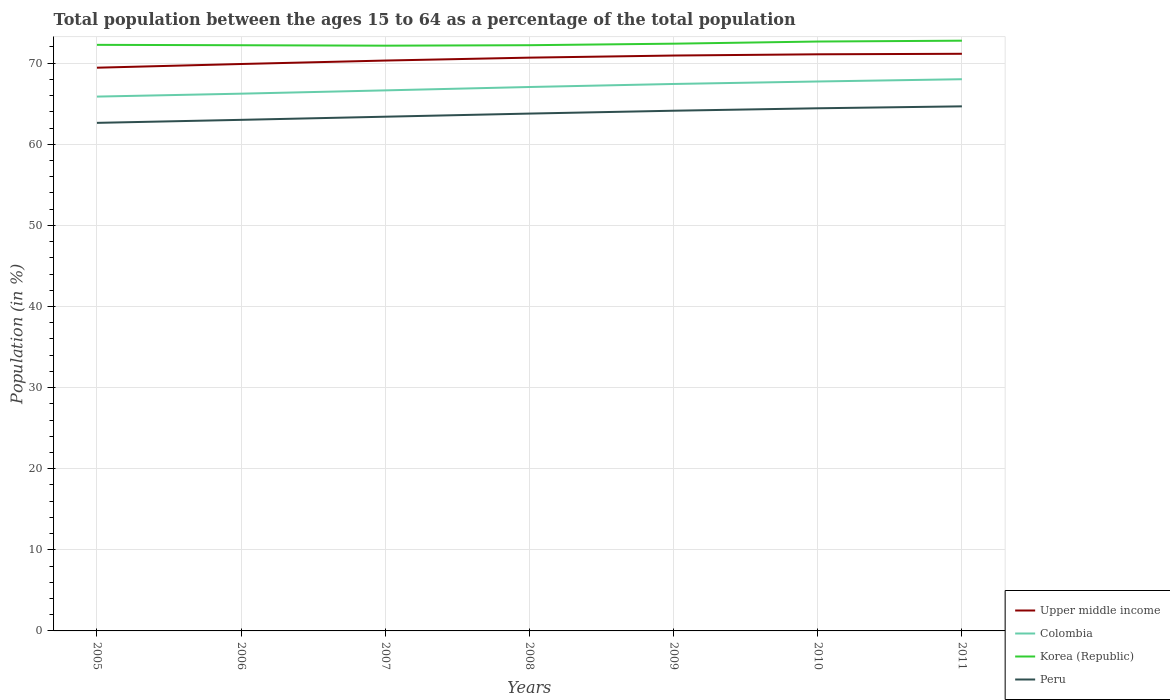Across all years, what is the maximum percentage of the population ages 15 to 64 in Korea (Republic)?
Your answer should be compact. 72.16. In which year was the percentage of the population ages 15 to 64 in Peru maximum?
Keep it short and to the point. 2005. What is the total percentage of the population ages 15 to 64 in Korea (Republic) in the graph?
Provide a short and direct response. -0.25. What is the difference between the highest and the second highest percentage of the population ages 15 to 64 in Peru?
Provide a succinct answer. 2.04. What is the difference between the highest and the lowest percentage of the population ages 15 to 64 in Upper middle income?
Make the answer very short. 4. Are the values on the major ticks of Y-axis written in scientific E-notation?
Ensure brevity in your answer.  No. Does the graph contain any zero values?
Ensure brevity in your answer.  No. Where does the legend appear in the graph?
Make the answer very short. Bottom right. How many legend labels are there?
Give a very brief answer. 4. How are the legend labels stacked?
Offer a terse response. Vertical. What is the title of the graph?
Your answer should be very brief. Total population between the ages 15 to 64 as a percentage of the total population. Does "American Samoa" appear as one of the legend labels in the graph?
Offer a very short reply. No. What is the Population (in %) in Upper middle income in 2005?
Ensure brevity in your answer.  69.44. What is the Population (in %) in Colombia in 2005?
Ensure brevity in your answer.  65.88. What is the Population (in %) of Korea (Republic) in 2005?
Ensure brevity in your answer.  72.26. What is the Population (in %) in Peru in 2005?
Ensure brevity in your answer.  62.64. What is the Population (in %) in Upper middle income in 2006?
Your answer should be compact. 69.9. What is the Population (in %) of Colombia in 2006?
Provide a succinct answer. 66.24. What is the Population (in %) of Korea (Republic) in 2006?
Your answer should be very brief. 72.21. What is the Population (in %) of Peru in 2006?
Offer a very short reply. 63.01. What is the Population (in %) in Upper middle income in 2007?
Keep it short and to the point. 70.33. What is the Population (in %) of Colombia in 2007?
Provide a succinct answer. 66.65. What is the Population (in %) in Korea (Republic) in 2007?
Give a very brief answer. 72.16. What is the Population (in %) of Peru in 2007?
Offer a very short reply. 63.4. What is the Population (in %) in Upper middle income in 2008?
Ensure brevity in your answer.  70.68. What is the Population (in %) of Colombia in 2008?
Offer a very short reply. 67.06. What is the Population (in %) in Korea (Republic) in 2008?
Your response must be concise. 72.22. What is the Population (in %) of Peru in 2008?
Keep it short and to the point. 63.79. What is the Population (in %) in Upper middle income in 2009?
Make the answer very short. 70.94. What is the Population (in %) of Colombia in 2009?
Offer a very short reply. 67.44. What is the Population (in %) in Korea (Republic) in 2009?
Offer a terse response. 72.41. What is the Population (in %) of Peru in 2009?
Keep it short and to the point. 64.14. What is the Population (in %) in Upper middle income in 2010?
Provide a short and direct response. 71.1. What is the Population (in %) of Colombia in 2010?
Provide a succinct answer. 67.74. What is the Population (in %) in Korea (Republic) in 2010?
Your answer should be compact. 72.67. What is the Population (in %) in Peru in 2010?
Your answer should be very brief. 64.44. What is the Population (in %) of Upper middle income in 2011?
Your answer should be very brief. 71.16. What is the Population (in %) in Colombia in 2011?
Give a very brief answer. 68.02. What is the Population (in %) of Korea (Republic) in 2011?
Keep it short and to the point. 72.77. What is the Population (in %) in Peru in 2011?
Keep it short and to the point. 64.68. Across all years, what is the maximum Population (in %) in Upper middle income?
Provide a succinct answer. 71.16. Across all years, what is the maximum Population (in %) in Colombia?
Your answer should be very brief. 68.02. Across all years, what is the maximum Population (in %) in Korea (Republic)?
Your answer should be very brief. 72.77. Across all years, what is the maximum Population (in %) of Peru?
Offer a terse response. 64.68. Across all years, what is the minimum Population (in %) of Upper middle income?
Provide a short and direct response. 69.44. Across all years, what is the minimum Population (in %) in Colombia?
Your answer should be very brief. 65.88. Across all years, what is the minimum Population (in %) of Korea (Republic)?
Your answer should be very brief. 72.16. Across all years, what is the minimum Population (in %) in Peru?
Your answer should be compact. 62.64. What is the total Population (in %) of Upper middle income in the graph?
Keep it short and to the point. 493.55. What is the total Population (in %) in Colombia in the graph?
Give a very brief answer. 469.04. What is the total Population (in %) in Korea (Republic) in the graph?
Make the answer very short. 506.7. What is the total Population (in %) in Peru in the graph?
Offer a terse response. 446.11. What is the difference between the Population (in %) of Upper middle income in 2005 and that in 2006?
Your answer should be compact. -0.46. What is the difference between the Population (in %) of Colombia in 2005 and that in 2006?
Offer a very short reply. -0.36. What is the difference between the Population (in %) in Korea (Republic) in 2005 and that in 2006?
Keep it short and to the point. 0.05. What is the difference between the Population (in %) of Peru in 2005 and that in 2006?
Make the answer very short. -0.37. What is the difference between the Population (in %) in Upper middle income in 2005 and that in 2007?
Provide a short and direct response. -0.88. What is the difference between the Population (in %) in Colombia in 2005 and that in 2007?
Your answer should be compact. -0.77. What is the difference between the Population (in %) of Korea (Republic) in 2005 and that in 2007?
Keep it short and to the point. 0.1. What is the difference between the Population (in %) in Peru in 2005 and that in 2007?
Your answer should be compact. -0.76. What is the difference between the Population (in %) of Upper middle income in 2005 and that in 2008?
Your answer should be very brief. -1.24. What is the difference between the Population (in %) in Colombia in 2005 and that in 2008?
Your answer should be very brief. -1.18. What is the difference between the Population (in %) of Korea (Republic) in 2005 and that in 2008?
Your response must be concise. 0.05. What is the difference between the Population (in %) in Peru in 2005 and that in 2008?
Make the answer very short. -1.14. What is the difference between the Population (in %) of Upper middle income in 2005 and that in 2009?
Ensure brevity in your answer.  -1.5. What is the difference between the Population (in %) in Colombia in 2005 and that in 2009?
Your answer should be compact. -1.56. What is the difference between the Population (in %) in Korea (Republic) in 2005 and that in 2009?
Keep it short and to the point. -0.14. What is the difference between the Population (in %) in Peru in 2005 and that in 2009?
Make the answer very short. -1.5. What is the difference between the Population (in %) in Upper middle income in 2005 and that in 2010?
Provide a short and direct response. -1.65. What is the difference between the Population (in %) of Colombia in 2005 and that in 2010?
Your answer should be compact. -1.86. What is the difference between the Population (in %) of Korea (Republic) in 2005 and that in 2010?
Offer a terse response. -0.41. What is the difference between the Population (in %) in Peru in 2005 and that in 2010?
Provide a succinct answer. -1.8. What is the difference between the Population (in %) in Upper middle income in 2005 and that in 2011?
Your answer should be very brief. -1.72. What is the difference between the Population (in %) in Colombia in 2005 and that in 2011?
Your response must be concise. -2.14. What is the difference between the Population (in %) in Korea (Republic) in 2005 and that in 2011?
Offer a very short reply. -0.51. What is the difference between the Population (in %) in Peru in 2005 and that in 2011?
Give a very brief answer. -2.04. What is the difference between the Population (in %) of Upper middle income in 2006 and that in 2007?
Keep it short and to the point. -0.43. What is the difference between the Population (in %) in Colombia in 2006 and that in 2007?
Offer a terse response. -0.41. What is the difference between the Population (in %) in Korea (Republic) in 2006 and that in 2007?
Give a very brief answer. 0.05. What is the difference between the Population (in %) of Peru in 2006 and that in 2007?
Make the answer very short. -0.39. What is the difference between the Population (in %) in Upper middle income in 2006 and that in 2008?
Provide a short and direct response. -0.78. What is the difference between the Population (in %) of Colombia in 2006 and that in 2008?
Provide a succinct answer. -0.82. What is the difference between the Population (in %) of Korea (Republic) in 2006 and that in 2008?
Ensure brevity in your answer.  -0. What is the difference between the Population (in %) of Peru in 2006 and that in 2008?
Your response must be concise. -0.77. What is the difference between the Population (in %) in Upper middle income in 2006 and that in 2009?
Keep it short and to the point. -1.04. What is the difference between the Population (in %) in Colombia in 2006 and that in 2009?
Keep it short and to the point. -1.2. What is the difference between the Population (in %) in Korea (Republic) in 2006 and that in 2009?
Provide a short and direct response. -0.19. What is the difference between the Population (in %) of Peru in 2006 and that in 2009?
Offer a very short reply. -1.13. What is the difference between the Population (in %) of Upper middle income in 2006 and that in 2010?
Your response must be concise. -1.2. What is the difference between the Population (in %) in Colombia in 2006 and that in 2010?
Your answer should be very brief. -1.5. What is the difference between the Population (in %) in Korea (Republic) in 2006 and that in 2010?
Your answer should be very brief. -0.46. What is the difference between the Population (in %) of Peru in 2006 and that in 2010?
Your answer should be very brief. -1.43. What is the difference between the Population (in %) in Upper middle income in 2006 and that in 2011?
Make the answer very short. -1.26. What is the difference between the Population (in %) of Colombia in 2006 and that in 2011?
Ensure brevity in your answer.  -1.78. What is the difference between the Population (in %) of Korea (Republic) in 2006 and that in 2011?
Give a very brief answer. -0.56. What is the difference between the Population (in %) of Peru in 2006 and that in 2011?
Provide a short and direct response. -1.66. What is the difference between the Population (in %) of Upper middle income in 2007 and that in 2008?
Provide a succinct answer. -0.36. What is the difference between the Population (in %) of Colombia in 2007 and that in 2008?
Keep it short and to the point. -0.42. What is the difference between the Population (in %) in Korea (Republic) in 2007 and that in 2008?
Offer a terse response. -0.06. What is the difference between the Population (in %) in Peru in 2007 and that in 2008?
Offer a very short reply. -0.39. What is the difference between the Population (in %) of Upper middle income in 2007 and that in 2009?
Your answer should be very brief. -0.62. What is the difference between the Population (in %) of Colombia in 2007 and that in 2009?
Offer a terse response. -0.79. What is the difference between the Population (in %) of Korea (Republic) in 2007 and that in 2009?
Ensure brevity in your answer.  -0.25. What is the difference between the Population (in %) in Peru in 2007 and that in 2009?
Make the answer very short. -0.74. What is the difference between the Population (in %) in Upper middle income in 2007 and that in 2010?
Keep it short and to the point. -0.77. What is the difference between the Population (in %) of Colombia in 2007 and that in 2010?
Your response must be concise. -1.1. What is the difference between the Population (in %) in Korea (Republic) in 2007 and that in 2010?
Your response must be concise. -0.51. What is the difference between the Population (in %) of Peru in 2007 and that in 2010?
Give a very brief answer. -1.04. What is the difference between the Population (in %) in Upper middle income in 2007 and that in 2011?
Provide a succinct answer. -0.83. What is the difference between the Population (in %) in Colombia in 2007 and that in 2011?
Give a very brief answer. -1.38. What is the difference between the Population (in %) of Korea (Republic) in 2007 and that in 2011?
Provide a short and direct response. -0.62. What is the difference between the Population (in %) in Peru in 2007 and that in 2011?
Offer a very short reply. -1.28. What is the difference between the Population (in %) of Upper middle income in 2008 and that in 2009?
Your answer should be very brief. -0.26. What is the difference between the Population (in %) of Colombia in 2008 and that in 2009?
Your answer should be compact. -0.37. What is the difference between the Population (in %) of Korea (Republic) in 2008 and that in 2009?
Keep it short and to the point. -0.19. What is the difference between the Population (in %) in Peru in 2008 and that in 2009?
Offer a very short reply. -0.35. What is the difference between the Population (in %) in Upper middle income in 2008 and that in 2010?
Make the answer very short. -0.41. What is the difference between the Population (in %) in Colombia in 2008 and that in 2010?
Keep it short and to the point. -0.68. What is the difference between the Population (in %) of Korea (Republic) in 2008 and that in 2010?
Make the answer very short. -0.45. What is the difference between the Population (in %) in Peru in 2008 and that in 2010?
Keep it short and to the point. -0.65. What is the difference between the Population (in %) in Upper middle income in 2008 and that in 2011?
Give a very brief answer. -0.47. What is the difference between the Population (in %) of Colombia in 2008 and that in 2011?
Provide a short and direct response. -0.96. What is the difference between the Population (in %) of Korea (Republic) in 2008 and that in 2011?
Your answer should be compact. -0.56. What is the difference between the Population (in %) of Peru in 2008 and that in 2011?
Offer a very short reply. -0.89. What is the difference between the Population (in %) of Upper middle income in 2009 and that in 2010?
Your response must be concise. -0.15. What is the difference between the Population (in %) of Colombia in 2009 and that in 2010?
Provide a short and direct response. -0.31. What is the difference between the Population (in %) of Korea (Republic) in 2009 and that in 2010?
Offer a terse response. -0.27. What is the difference between the Population (in %) in Upper middle income in 2009 and that in 2011?
Offer a terse response. -0.21. What is the difference between the Population (in %) of Colombia in 2009 and that in 2011?
Your answer should be very brief. -0.59. What is the difference between the Population (in %) of Korea (Republic) in 2009 and that in 2011?
Your answer should be compact. -0.37. What is the difference between the Population (in %) in Peru in 2009 and that in 2011?
Your answer should be very brief. -0.54. What is the difference between the Population (in %) of Upper middle income in 2010 and that in 2011?
Offer a terse response. -0.06. What is the difference between the Population (in %) in Colombia in 2010 and that in 2011?
Make the answer very short. -0.28. What is the difference between the Population (in %) in Korea (Republic) in 2010 and that in 2011?
Offer a terse response. -0.1. What is the difference between the Population (in %) in Peru in 2010 and that in 2011?
Offer a very short reply. -0.24. What is the difference between the Population (in %) in Upper middle income in 2005 and the Population (in %) in Colombia in 2006?
Give a very brief answer. 3.2. What is the difference between the Population (in %) of Upper middle income in 2005 and the Population (in %) of Korea (Republic) in 2006?
Your answer should be very brief. -2.77. What is the difference between the Population (in %) of Upper middle income in 2005 and the Population (in %) of Peru in 2006?
Provide a short and direct response. 6.43. What is the difference between the Population (in %) of Colombia in 2005 and the Population (in %) of Korea (Republic) in 2006?
Provide a succinct answer. -6.33. What is the difference between the Population (in %) in Colombia in 2005 and the Population (in %) in Peru in 2006?
Your answer should be very brief. 2.87. What is the difference between the Population (in %) of Korea (Republic) in 2005 and the Population (in %) of Peru in 2006?
Give a very brief answer. 9.25. What is the difference between the Population (in %) of Upper middle income in 2005 and the Population (in %) of Colombia in 2007?
Your answer should be very brief. 2.8. What is the difference between the Population (in %) of Upper middle income in 2005 and the Population (in %) of Korea (Republic) in 2007?
Keep it short and to the point. -2.72. What is the difference between the Population (in %) of Upper middle income in 2005 and the Population (in %) of Peru in 2007?
Your answer should be very brief. 6.04. What is the difference between the Population (in %) in Colombia in 2005 and the Population (in %) in Korea (Republic) in 2007?
Give a very brief answer. -6.28. What is the difference between the Population (in %) in Colombia in 2005 and the Population (in %) in Peru in 2007?
Keep it short and to the point. 2.48. What is the difference between the Population (in %) of Korea (Republic) in 2005 and the Population (in %) of Peru in 2007?
Ensure brevity in your answer.  8.86. What is the difference between the Population (in %) of Upper middle income in 2005 and the Population (in %) of Colombia in 2008?
Your response must be concise. 2.38. What is the difference between the Population (in %) of Upper middle income in 2005 and the Population (in %) of Korea (Republic) in 2008?
Provide a succinct answer. -2.77. What is the difference between the Population (in %) in Upper middle income in 2005 and the Population (in %) in Peru in 2008?
Offer a very short reply. 5.66. What is the difference between the Population (in %) in Colombia in 2005 and the Population (in %) in Korea (Republic) in 2008?
Offer a very short reply. -6.34. What is the difference between the Population (in %) of Colombia in 2005 and the Population (in %) of Peru in 2008?
Your answer should be compact. 2.09. What is the difference between the Population (in %) of Korea (Republic) in 2005 and the Population (in %) of Peru in 2008?
Provide a succinct answer. 8.48. What is the difference between the Population (in %) in Upper middle income in 2005 and the Population (in %) in Colombia in 2009?
Offer a terse response. 2.01. What is the difference between the Population (in %) of Upper middle income in 2005 and the Population (in %) of Korea (Republic) in 2009?
Provide a short and direct response. -2.96. What is the difference between the Population (in %) of Upper middle income in 2005 and the Population (in %) of Peru in 2009?
Give a very brief answer. 5.3. What is the difference between the Population (in %) of Colombia in 2005 and the Population (in %) of Korea (Republic) in 2009?
Your answer should be compact. -6.52. What is the difference between the Population (in %) of Colombia in 2005 and the Population (in %) of Peru in 2009?
Keep it short and to the point. 1.74. What is the difference between the Population (in %) of Korea (Republic) in 2005 and the Population (in %) of Peru in 2009?
Provide a succinct answer. 8.12. What is the difference between the Population (in %) in Upper middle income in 2005 and the Population (in %) in Colombia in 2010?
Give a very brief answer. 1.7. What is the difference between the Population (in %) in Upper middle income in 2005 and the Population (in %) in Korea (Republic) in 2010?
Your answer should be very brief. -3.23. What is the difference between the Population (in %) of Upper middle income in 2005 and the Population (in %) of Peru in 2010?
Your response must be concise. 5. What is the difference between the Population (in %) in Colombia in 2005 and the Population (in %) in Korea (Republic) in 2010?
Offer a very short reply. -6.79. What is the difference between the Population (in %) of Colombia in 2005 and the Population (in %) of Peru in 2010?
Your answer should be compact. 1.44. What is the difference between the Population (in %) in Korea (Republic) in 2005 and the Population (in %) in Peru in 2010?
Offer a very short reply. 7.82. What is the difference between the Population (in %) in Upper middle income in 2005 and the Population (in %) in Colombia in 2011?
Offer a very short reply. 1.42. What is the difference between the Population (in %) of Upper middle income in 2005 and the Population (in %) of Korea (Republic) in 2011?
Give a very brief answer. -3.33. What is the difference between the Population (in %) of Upper middle income in 2005 and the Population (in %) of Peru in 2011?
Give a very brief answer. 4.76. What is the difference between the Population (in %) in Colombia in 2005 and the Population (in %) in Korea (Republic) in 2011?
Give a very brief answer. -6.89. What is the difference between the Population (in %) in Colombia in 2005 and the Population (in %) in Peru in 2011?
Keep it short and to the point. 1.2. What is the difference between the Population (in %) of Korea (Republic) in 2005 and the Population (in %) of Peru in 2011?
Keep it short and to the point. 7.58. What is the difference between the Population (in %) of Upper middle income in 2006 and the Population (in %) of Colombia in 2007?
Provide a short and direct response. 3.25. What is the difference between the Population (in %) in Upper middle income in 2006 and the Population (in %) in Korea (Republic) in 2007?
Your answer should be compact. -2.26. What is the difference between the Population (in %) of Upper middle income in 2006 and the Population (in %) of Peru in 2007?
Give a very brief answer. 6.5. What is the difference between the Population (in %) of Colombia in 2006 and the Population (in %) of Korea (Republic) in 2007?
Provide a succinct answer. -5.92. What is the difference between the Population (in %) of Colombia in 2006 and the Population (in %) of Peru in 2007?
Provide a short and direct response. 2.84. What is the difference between the Population (in %) in Korea (Republic) in 2006 and the Population (in %) in Peru in 2007?
Ensure brevity in your answer.  8.81. What is the difference between the Population (in %) in Upper middle income in 2006 and the Population (in %) in Colombia in 2008?
Make the answer very short. 2.84. What is the difference between the Population (in %) of Upper middle income in 2006 and the Population (in %) of Korea (Republic) in 2008?
Provide a succinct answer. -2.32. What is the difference between the Population (in %) of Upper middle income in 2006 and the Population (in %) of Peru in 2008?
Your answer should be compact. 6.11. What is the difference between the Population (in %) of Colombia in 2006 and the Population (in %) of Korea (Republic) in 2008?
Ensure brevity in your answer.  -5.97. What is the difference between the Population (in %) in Colombia in 2006 and the Population (in %) in Peru in 2008?
Your response must be concise. 2.45. What is the difference between the Population (in %) in Korea (Republic) in 2006 and the Population (in %) in Peru in 2008?
Provide a succinct answer. 8.43. What is the difference between the Population (in %) of Upper middle income in 2006 and the Population (in %) of Colombia in 2009?
Provide a succinct answer. 2.46. What is the difference between the Population (in %) in Upper middle income in 2006 and the Population (in %) in Korea (Republic) in 2009?
Offer a terse response. -2.51. What is the difference between the Population (in %) in Upper middle income in 2006 and the Population (in %) in Peru in 2009?
Make the answer very short. 5.76. What is the difference between the Population (in %) in Colombia in 2006 and the Population (in %) in Korea (Republic) in 2009?
Offer a very short reply. -6.16. What is the difference between the Population (in %) in Colombia in 2006 and the Population (in %) in Peru in 2009?
Keep it short and to the point. 2.1. What is the difference between the Population (in %) in Korea (Republic) in 2006 and the Population (in %) in Peru in 2009?
Your answer should be very brief. 8.07. What is the difference between the Population (in %) of Upper middle income in 2006 and the Population (in %) of Colombia in 2010?
Offer a very short reply. 2.16. What is the difference between the Population (in %) of Upper middle income in 2006 and the Population (in %) of Korea (Republic) in 2010?
Offer a terse response. -2.77. What is the difference between the Population (in %) in Upper middle income in 2006 and the Population (in %) in Peru in 2010?
Your response must be concise. 5.46. What is the difference between the Population (in %) in Colombia in 2006 and the Population (in %) in Korea (Republic) in 2010?
Keep it short and to the point. -6.43. What is the difference between the Population (in %) of Colombia in 2006 and the Population (in %) of Peru in 2010?
Provide a short and direct response. 1.8. What is the difference between the Population (in %) of Korea (Republic) in 2006 and the Population (in %) of Peru in 2010?
Make the answer very short. 7.77. What is the difference between the Population (in %) in Upper middle income in 2006 and the Population (in %) in Colombia in 2011?
Provide a succinct answer. 1.88. What is the difference between the Population (in %) of Upper middle income in 2006 and the Population (in %) of Korea (Republic) in 2011?
Keep it short and to the point. -2.87. What is the difference between the Population (in %) of Upper middle income in 2006 and the Population (in %) of Peru in 2011?
Offer a terse response. 5.22. What is the difference between the Population (in %) in Colombia in 2006 and the Population (in %) in Korea (Republic) in 2011?
Your answer should be compact. -6.53. What is the difference between the Population (in %) in Colombia in 2006 and the Population (in %) in Peru in 2011?
Ensure brevity in your answer.  1.56. What is the difference between the Population (in %) of Korea (Republic) in 2006 and the Population (in %) of Peru in 2011?
Ensure brevity in your answer.  7.53. What is the difference between the Population (in %) in Upper middle income in 2007 and the Population (in %) in Colombia in 2008?
Your response must be concise. 3.26. What is the difference between the Population (in %) of Upper middle income in 2007 and the Population (in %) of Korea (Republic) in 2008?
Provide a short and direct response. -1.89. What is the difference between the Population (in %) of Upper middle income in 2007 and the Population (in %) of Peru in 2008?
Provide a succinct answer. 6.54. What is the difference between the Population (in %) in Colombia in 2007 and the Population (in %) in Korea (Republic) in 2008?
Provide a succinct answer. -5.57. What is the difference between the Population (in %) in Colombia in 2007 and the Population (in %) in Peru in 2008?
Your answer should be very brief. 2.86. What is the difference between the Population (in %) of Korea (Republic) in 2007 and the Population (in %) of Peru in 2008?
Ensure brevity in your answer.  8.37. What is the difference between the Population (in %) of Upper middle income in 2007 and the Population (in %) of Colombia in 2009?
Provide a short and direct response. 2.89. What is the difference between the Population (in %) in Upper middle income in 2007 and the Population (in %) in Korea (Republic) in 2009?
Offer a terse response. -2.08. What is the difference between the Population (in %) in Upper middle income in 2007 and the Population (in %) in Peru in 2009?
Keep it short and to the point. 6.19. What is the difference between the Population (in %) of Colombia in 2007 and the Population (in %) of Korea (Republic) in 2009?
Offer a terse response. -5.76. What is the difference between the Population (in %) in Colombia in 2007 and the Population (in %) in Peru in 2009?
Ensure brevity in your answer.  2.51. What is the difference between the Population (in %) of Korea (Republic) in 2007 and the Population (in %) of Peru in 2009?
Your response must be concise. 8.02. What is the difference between the Population (in %) of Upper middle income in 2007 and the Population (in %) of Colombia in 2010?
Provide a succinct answer. 2.58. What is the difference between the Population (in %) of Upper middle income in 2007 and the Population (in %) of Korea (Republic) in 2010?
Offer a terse response. -2.35. What is the difference between the Population (in %) of Upper middle income in 2007 and the Population (in %) of Peru in 2010?
Your answer should be very brief. 5.89. What is the difference between the Population (in %) in Colombia in 2007 and the Population (in %) in Korea (Republic) in 2010?
Your answer should be very brief. -6.02. What is the difference between the Population (in %) in Colombia in 2007 and the Population (in %) in Peru in 2010?
Keep it short and to the point. 2.21. What is the difference between the Population (in %) in Korea (Republic) in 2007 and the Population (in %) in Peru in 2010?
Provide a succinct answer. 7.72. What is the difference between the Population (in %) in Upper middle income in 2007 and the Population (in %) in Colombia in 2011?
Ensure brevity in your answer.  2.3. What is the difference between the Population (in %) in Upper middle income in 2007 and the Population (in %) in Korea (Republic) in 2011?
Keep it short and to the point. -2.45. What is the difference between the Population (in %) of Upper middle income in 2007 and the Population (in %) of Peru in 2011?
Offer a terse response. 5.65. What is the difference between the Population (in %) in Colombia in 2007 and the Population (in %) in Korea (Republic) in 2011?
Keep it short and to the point. -6.13. What is the difference between the Population (in %) in Colombia in 2007 and the Population (in %) in Peru in 2011?
Make the answer very short. 1.97. What is the difference between the Population (in %) of Korea (Republic) in 2007 and the Population (in %) of Peru in 2011?
Give a very brief answer. 7.48. What is the difference between the Population (in %) of Upper middle income in 2008 and the Population (in %) of Colombia in 2009?
Provide a succinct answer. 3.25. What is the difference between the Population (in %) in Upper middle income in 2008 and the Population (in %) in Korea (Republic) in 2009?
Make the answer very short. -1.72. What is the difference between the Population (in %) in Upper middle income in 2008 and the Population (in %) in Peru in 2009?
Your answer should be very brief. 6.54. What is the difference between the Population (in %) in Colombia in 2008 and the Population (in %) in Korea (Republic) in 2009?
Ensure brevity in your answer.  -5.34. What is the difference between the Population (in %) in Colombia in 2008 and the Population (in %) in Peru in 2009?
Provide a short and direct response. 2.92. What is the difference between the Population (in %) in Korea (Republic) in 2008 and the Population (in %) in Peru in 2009?
Provide a short and direct response. 8.08. What is the difference between the Population (in %) of Upper middle income in 2008 and the Population (in %) of Colombia in 2010?
Your answer should be compact. 2.94. What is the difference between the Population (in %) in Upper middle income in 2008 and the Population (in %) in Korea (Republic) in 2010?
Your answer should be compact. -1.99. What is the difference between the Population (in %) in Upper middle income in 2008 and the Population (in %) in Peru in 2010?
Provide a succinct answer. 6.24. What is the difference between the Population (in %) in Colombia in 2008 and the Population (in %) in Korea (Republic) in 2010?
Keep it short and to the point. -5.61. What is the difference between the Population (in %) of Colombia in 2008 and the Population (in %) of Peru in 2010?
Your response must be concise. 2.62. What is the difference between the Population (in %) of Korea (Republic) in 2008 and the Population (in %) of Peru in 2010?
Your response must be concise. 7.78. What is the difference between the Population (in %) in Upper middle income in 2008 and the Population (in %) in Colombia in 2011?
Provide a short and direct response. 2.66. What is the difference between the Population (in %) of Upper middle income in 2008 and the Population (in %) of Korea (Republic) in 2011?
Your response must be concise. -2.09. What is the difference between the Population (in %) in Upper middle income in 2008 and the Population (in %) in Peru in 2011?
Offer a very short reply. 6.01. What is the difference between the Population (in %) of Colombia in 2008 and the Population (in %) of Korea (Republic) in 2011?
Provide a succinct answer. -5.71. What is the difference between the Population (in %) in Colombia in 2008 and the Population (in %) in Peru in 2011?
Your answer should be compact. 2.39. What is the difference between the Population (in %) in Korea (Republic) in 2008 and the Population (in %) in Peru in 2011?
Offer a very short reply. 7.54. What is the difference between the Population (in %) in Upper middle income in 2009 and the Population (in %) in Colombia in 2010?
Offer a terse response. 3.2. What is the difference between the Population (in %) in Upper middle income in 2009 and the Population (in %) in Korea (Republic) in 2010?
Give a very brief answer. -1.73. What is the difference between the Population (in %) of Upper middle income in 2009 and the Population (in %) of Peru in 2010?
Provide a succinct answer. 6.5. What is the difference between the Population (in %) of Colombia in 2009 and the Population (in %) of Korea (Republic) in 2010?
Offer a very short reply. -5.23. What is the difference between the Population (in %) in Colombia in 2009 and the Population (in %) in Peru in 2010?
Keep it short and to the point. 3. What is the difference between the Population (in %) in Korea (Republic) in 2009 and the Population (in %) in Peru in 2010?
Make the answer very short. 7.97. What is the difference between the Population (in %) in Upper middle income in 2009 and the Population (in %) in Colombia in 2011?
Make the answer very short. 2.92. What is the difference between the Population (in %) in Upper middle income in 2009 and the Population (in %) in Korea (Republic) in 2011?
Your answer should be compact. -1.83. What is the difference between the Population (in %) in Upper middle income in 2009 and the Population (in %) in Peru in 2011?
Make the answer very short. 6.27. What is the difference between the Population (in %) of Colombia in 2009 and the Population (in %) of Korea (Republic) in 2011?
Provide a succinct answer. -5.34. What is the difference between the Population (in %) of Colombia in 2009 and the Population (in %) of Peru in 2011?
Your response must be concise. 2.76. What is the difference between the Population (in %) in Korea (Republic) in 2009 and the Population (in %) in Peru in 2011?
Make the answer very short. 7.73. What is the difference between the Population (in %) in Upper middle income in 2010 and the Population (in %) in Colombia in 2011?
Give a very brief answer. 3.07. What is the difference between the Population (in %) in Upper middle income in 2010 and the Population (in %) in Korea (Republic) in 2011?
Your answer should be very brief. -1.68. What is the difference between the Population (in %) in Upper middle income in 2010 and the Population (in %) in Peru in 2011?
Make the answer very short. 6.42. What is the difference between the Population (in %) of Colombia in 2010 and the Population (in %) of Korea (Republic) in 2011?
Your answer should be compact. -5.03. What is the difference between the Population (in %) in Colombia in 2010 and the Population (in %) in Peru in 2011?
Give a very brief answer. 3.07. What is the difference between the Population (in %) of Korea (Republic) in 2010 and the Population (in %) of Peru in 2011?
Keep it short and to the point. 7.99. What is the average Population (in %) in Upper middle income per year?
Your answer should be very brief. 70.51. What is the average Population (in %) of Colombia per year?
Your answer should be compact. 67.01. What is the average Population (in %) of Korea (Republic) per year?
Your response must be concise. 72.39. What is the average Population (in %) in Peru per year?
Your answer should be compact. 63.73. In the year 2005, what is the difference between the Population (in %) of Upper middle income and Population (in %) of Colombia?
Your response must be concise. 3.56. In the year 2005, what is the difference between the Population (in %) of Upper middle income and Population (in %) of Korea (Republic)?
Provide a short and direct response. -2.82. In the year 2005, what is the difference between the Population (in %) of Upper middle income and Population (in %) of Peru?
Offer a terse response. 6.8. In the year 2005, what is the difference between the Population (in %) of Colombia and Population (in %) of Korea (Republic)?
Provide a short and direct response. -6.38. In the year 2005, what is the difference between the Population (in %) of Colombia and Population (in %) of Peru?
Make the answer very short. 3.24. In the year 2005, what is the difference between the Population (in %) of Korea (Republic) and Population (in %) of Peru?
Your response must be concise. 9.62. In the year 2006, what is the difference between the Population (in %) in Upper middle income and Population (in %) in Colombia?
Keep it short and to the point. 3.66. In the year 2006, what is the difference between the Population (in %) of Upper middle income and Population (in %) of Korea (Republic)?
Provide a succinct answer. -2.31. In the year 2006, what is the difference between the Population (in %) in Upper middle income and Population (in %) in Peru?
Make the answer very short. 6.89. In the year 2006, what is the difference between the Population (in %) of Colombia and Population (in %) of Korea (Republic)?
Your answer should be compact. -5.97. In the year 2006, what is the difference between the Population (in %) of Colombia and Population (in %) of Peru?
Offer a very short reply. 3.23. In the year 2006, what is the difference between the Population (in %) in Korea (Republic) and Population (in %) in Peru?
Make the answer very short. 9.2. In the year 2007, what is the difference between the Population (in %) of Upper middle income and Population (in %) of Colombia?
Ensure brevity in your answer.  3.68. In the year 2007, what is the difference between the Population (in %) in Upper middle income and Population (in %) in Korea (Republic)?
Provide a succinct answer. -1.83. In the year 2007, what is the difference between the Population (in %) in Upper middle income and Population (in %) in Peru?
Your answer should be compact. 6.92. In the year 2007, what is the difference between the Population (in %) of Colombia and Population (in %) of Korea (Republic)?
Provide a short and direct response. -5.51. In the year 2007, what is the difference between the Population (in %) in Colombia and Population (in %) in Peru?
Provide a short and direct response. 3.25. In the year 2007, what is the difference between the Population (in %) in Korea (Republic) and Population (in %) in Peru?
Your answer should be compact. 8.76. In the year 2008, what is the difference between the Population (in %) of Upper middle income and Population (in %) of Colombia?
Ensure brevity in your answer.  3.62. In the year 2008, what is the difference between the Population (in %) in Upper middle income and Population (in %) in Korea (Republic)?
Keep it short and to the point. -1.53. In the year 2008, what is the difference between the Population (in %) of Upper middle income and Population (in %) of Peru?
Your response must be concise. 6.9. In the year 2008, what is the difference between the Population (in %) of Colombia and Population (in %) of Korea (Republic)?
Your response must be concise. -5.15. In the year 2008, what is the difference between the Population (in %) in Colombia and Population (in %) in Peru?
Make the answer very short. 3.28. In the year 2008, what is the difference between the Population (in %) in Korea (Republic) and Population (in %) in Peru?
Provide a short and direct response. 8.43. In the year 2009, what is the difference between the Population (in %) in Upper middle income and Population (in %) in Colombia?
Your response must be concise. 3.51. In the year 2009, what is the difference between the Population (in %) of Upper middle income and Population (in %) of Korea (Republic)?
Offer a very short reply. -1.46. In the year 2009, what is the difference between the Population (in %) in Upper middle income and Population (in %) in Peru?
Your answer should be compact. 6.8. In the year 2009, what is the difference between the Population (in %) of Colombia and Population (in %) of Korea (Republic)?
Keep it short and to the point. -4.97. In the year 2009, what is the difference between the Population (in %) of Colombia and Population (in %) of Peru?
Provide a succinct answer. 3.3. In the year 2009, what is the difference between the Population (in %) of Korea (Republic) and Population (in %) of Peru?
Give a very brief answer. 8.27. In the year 2010, what is the difference between the Population (in %) in Upper middle income and Population (in %) in Colombia?
Your answer should be compact. 3.35. In the year 2010, what is the difference between the Population (in %) in Upper middle income and Population (in %) in Korea (Republic)?
Your answer should be very brief. -1.57. In the year 2010, what is the difference between the Population (in %) in Upper middle income and Population (in %) in Peru?
Make the answer very short. 6.66. In the year 2010, what is the difference between the Population (in %) in Colombia and Population (in %) in Korea (Republic)?
Your response must be concise. -4.93. In the year 2010, what is the difference between the Population (in %) of Colombia and Population (in %) of Peru?
Your answer should be compact. 3.3. In the year 2010, what is the difference between the Population (in %) of Korea (Republic) and Population (in %) of Peru?
Provide a succinct answer. 8.23. In the year 2011, what is the difference between the Population (in %) in Upper middle income and Population (in %) in Colombia?
Offer a terse response. 3.14. In the year 2011, what is the difference between the Population (in %) in Upper middle income and Population (in %) in Korea (Republic)?
Give a very brief answer. -1.62. In the year 2011, what is the difference between the Population (in %) in Upper middle income and Population (in %) in Peru?
Your response must be concise. 6.48. In the year 2011, what is the difference between the Population (in %) in Colombia and Population (in %) in Korea (Republic)?
Provide a short and direct response. -4.75. In the year 2011, what is the difference between the Population (in %) of Colombia and Population (in %) of Peru?
Your answer should be very brief. 3.35. In the year 2011, what is the difference between the Population (in %) of Korea (Republic) and Population (in %) of Peru?
Offer a terse response. 8.1. What is the ratio of the Population (in %) in Colombia in 2005 to that in 2006?
Give a very brief answer. 0.99. What is the ratio of the Population (in %) of Peru in 2005 to that in 2006?
Offer a very short reply. 0.99. What is the ratio of the Population (in %) of Upper middle income in 2005 to that in 2007?
Give a very brief answer. 0.99. What is the ratio of the Population (in %) in Peru in 2005 to that in 2007?
Offer a terse response. 0.99. What is the ratio of the Population (in %) of Upper middle income in 2005 to that in 2008?
Your answer should be compact. 0.98. What is the ratio of the Population (in %) in Colombia in 2005 to that in 2008?
Your answer should be very brief. 0.98. What is the ratio of the Population (in %) of Peru in 2005 to that in 2008?
Your answer should be compact. 0.98. What is the ratio of the Population (in %) in Upper middle income in 2005 to that in 2009?
Offer a terse response. 0.98. What is the ratio of the Population (in %) in Colombia in 2005 to that in 2009?
Offer a very short reply. 0.98. What is the ratio of the Population (in %) in Korea (Republic) in 2005 to that in 2009?
Give a very brief answer. 1. What is the ratio of the Population (in %) in Peru in 2005 to that in 2009?
Keep it short and to the point. 0.98. What is the ratio of the Population (in %) of Upper middle income in 2005 to that in 2010?
Provide a short and direct response. 0.98. What is the ratio of the Population (in %) of Colombia in 2005 to that in 2010?
Your response must be concise. 0.97. What is the ratio of the Population (in %) of Peru in 2005 to that in 2010?
Your answer should be very brief. 0.97. What is the ratio of the Population (in %) of Upper middle income in 2005 to that in 2011?
Keep it short and to the point. 0.98. What is the ratio of the Population (in %) in Colombia in 2005 to that in 2011?
Offer a very short reply. 0.97. What is the ratio of the Population (in %) in Peru in 2005 to that in 2011?
Your answer should be very brief. 0.97. What is the ratio of the Population (in %) in Upper middle income in 2006 to that in 2008?
Your answer should be compact. 0.99. What is the ratio of the Population (in %) in Colombia in 2006 to that in 2008?
Your answer should be very brief. 0.99. What is the ratio of the Population (in %) of Peru in 2006 to that in 2008?
Give a very brief answer. 0.99. What is the ratio of the Population (in %) of Upper middle income in 2006 to that in 2009?
Your answer should be compact. 0.99. What is the ratio of the Population (in %) of Colombia in 2006 to that in 2009?
Your answer should be very brief. 0.98. What is the ratio of the Population (in %) in Korea (Republic) in 2006 to that in 2009?
Provide a succinct answer. 1. What is the ratio of the Population (in %) of Peru in 2006 to that in 2009?
Keep it short and to the point. 0.98. What is the ratio of the Population (in %) in Upper middle income in 2006 to that in 2010?
Your response must be concise. 0.98. What is the ratio of the Population (in %) of Colombia in 2006 to that in 2010?
Your answer should be very brief. 0.98. What is the ratio of the Population (in %) of Peru in 2006 to that in 2010?
Offer a very short reply. 0.98. What is the ratio of the Population (in %) in Upper middle income in 2006 to that in 2011?
Offer a terse response. 0.98. What is the ratio of the Population (in %) in Colombia in 2006 to that in 2011?
Your response must be concise. 0.97. What is the ratio of the Population (in %) in Korea (Republic) in 2006 to that in 2011?
Ensure brevity in your answer.  0.99. What is the ratio of the Population (in %) of Peru in 2006 to that in 2011?
Your answer should be very brief. 0.97. What is the ratio of the Population (in %) of Colombia in 2007 to that in 2008?
Keep it short and to the point. 0.99. What is the ratio of the Population (in %) of Korea (Republic) in 2007 to that in 2008?
Make the answer very short. 1. What is the ratio of the Population (in %) in Peru in 2007 to that in 2008?
Keep it short and to the point. 0.99. What is the ratio of the Population (in %) in Colombia in 2007 to that in 2009?
Offer a terse response. 0.99. What is the ratio of the Population (in %) in Peru in 2007 to that in 2009?
Keep it short and to the point. 0.99. What is the ratio of the Population (in %) of Upper middle income in 2007 to that in 2010?
Keep it short and to the point. 0.99. What is the ratio of the Population (in %) of Colombia in 2007 to that in 2010?
Your answer should be very brief. 0.98. What is the ratio of the Population (in %) in Korea (Republic) in 2007 to that in 2010?
Ensure brevity in your answer.  0.99. What is the ratio of the Population (in %) in Peru in 2007 to that in 2010?
Offer a terse response. 0.98. What is the ratio of the Population (in %) of Upper middle income in 2007 to that in 2011?
Your answer should be very brief. 0.99. What is the ratio of the Population (in %) of Colombia in 2007 to that in 2011?
Give a very brief answer. 0.98. What is the ratio of the Population (in %) in Korea (Republic) in 2007 to that in 2011?
Keep it short and to the point. 0.99. What is the ratio of the Population (in %) in Peru in 2007 to that in 2011?
Offer a very short reply. 0.98. What is the ratio of the Population (in %) of Upper middle income in 2008 to that in 2009?
Offer a terse response. 1. What is the ratio of the Population (in %) of Colombia in 2008 to that in 2009?
Provide a succinct answer. 0.99. What is the ratio of the Population (in %) of Korea (Republic) in 2008 to that in 2009?
Ensure brevity in your answer.  1. What is the ratio of the Population (in %) in Upper middle income in 2008 to that in 2010?
Offer a terse response. 0.99. What is the ratio of the Population (in %) in Colombia in 2008 to that in 2010?
Your answer should be very brief. 0.99. What is the ratio of the Population (in %) of Korea (Republic) in 2008 to that in 2010?
Your answer should be compact. 0.99. What is the ratio of the Population (in %) of Colombia in 2008 to that in 2011?
Your answer should be very brief. 0.99. What is the ratio of the Population (in %) in Korea (Republic) in 2008 to that in 2011?
Ensure brevity in your answer.  0.99. What is the ratio of the Population (in %) in Peru in 2008 to that in 2011?
Make the answer very short. 0.99. What is the ratio of the Population (in %) in Korea (Republic) in 2009 to that in 2010?
Provide a succinct answer. 1. What is the ratio of the Population (in %) of Peru in 2009 to that in 2010?
Your answer should be very brief. 1. What is the ratio of the Population (in %) of Colombia in 2009 to that in 2011?
Ensure brevity in your answer.  0.99. What is the ratio of the Population (in %) in Korea (Republic) in 2009 to that in 2011?
Provide a short and direct response. 0.99. What is the ratio of the Population (in %) in Upper middle income in 2010 to that in 2011?
Offer a terse response. 1. What is the ratio of the Population (in %) in Korea (Republic) in 2010 to that in 2011?
Give a very brief answer. 1. What is the ratio of the Population (in %) of Peru in 2010 to that in 2011?
Provide a succinct answer. 1. What is the difference between the highest and the second highest Population (in %) of Upper middle income?
Provide a succinct answer. 0.06. What is the difference between the highest and the second highest Population (in %) of Colombia?
Give a very brief answer. 0.28. What is the difference between the highest and the second highest Population (in %) of Korea (Republic)?
Ensure brevity in your answer.  0.1. What is the difference between the highest and the second highest Population (in %) in Peru?
Your response must be concise. 0.24. What is the difference between the highest and the lowest Population (in %) of Upper middle income?
Your response must be concise. 1.72. What is the difference between the highest and the lowest Population (in %) in Colombia?
Provide a short and direct response. 2.14. What is the difference between the highest and the lowest Population (in %) in Korea (Republic)?
Keep it short and to the point. 0.62. What is the difference between the highest and the lowest Population (in %) of Peru?
Provide a short and direct response. 2.04. 